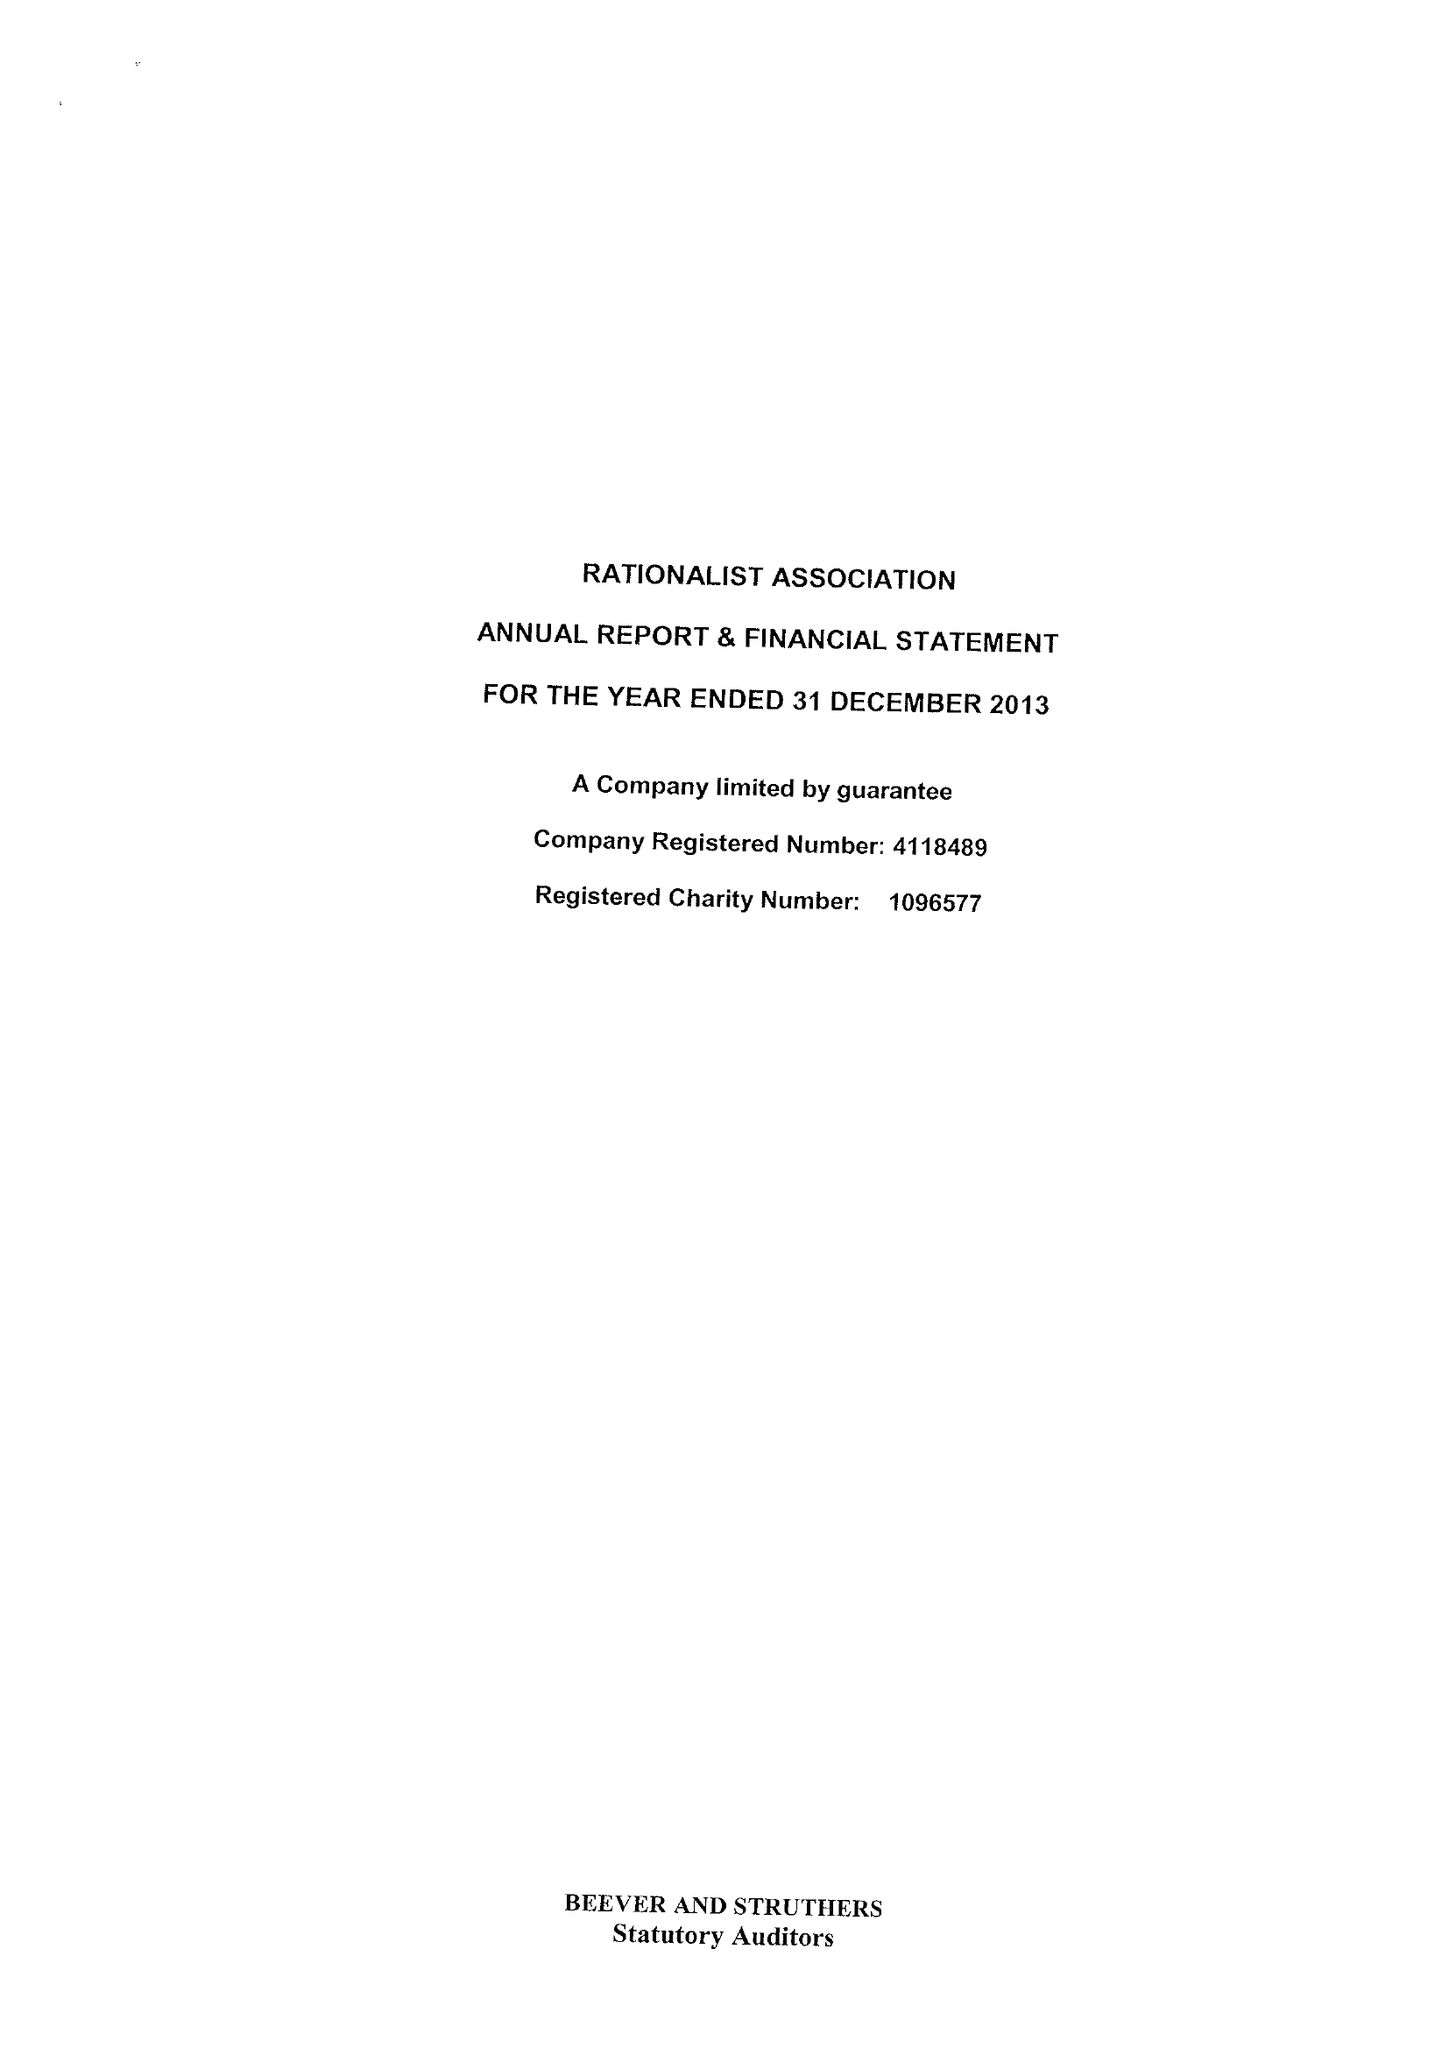What is the value for the address__postcode?
Answer the question using a single word or phrase. E2 9DA 